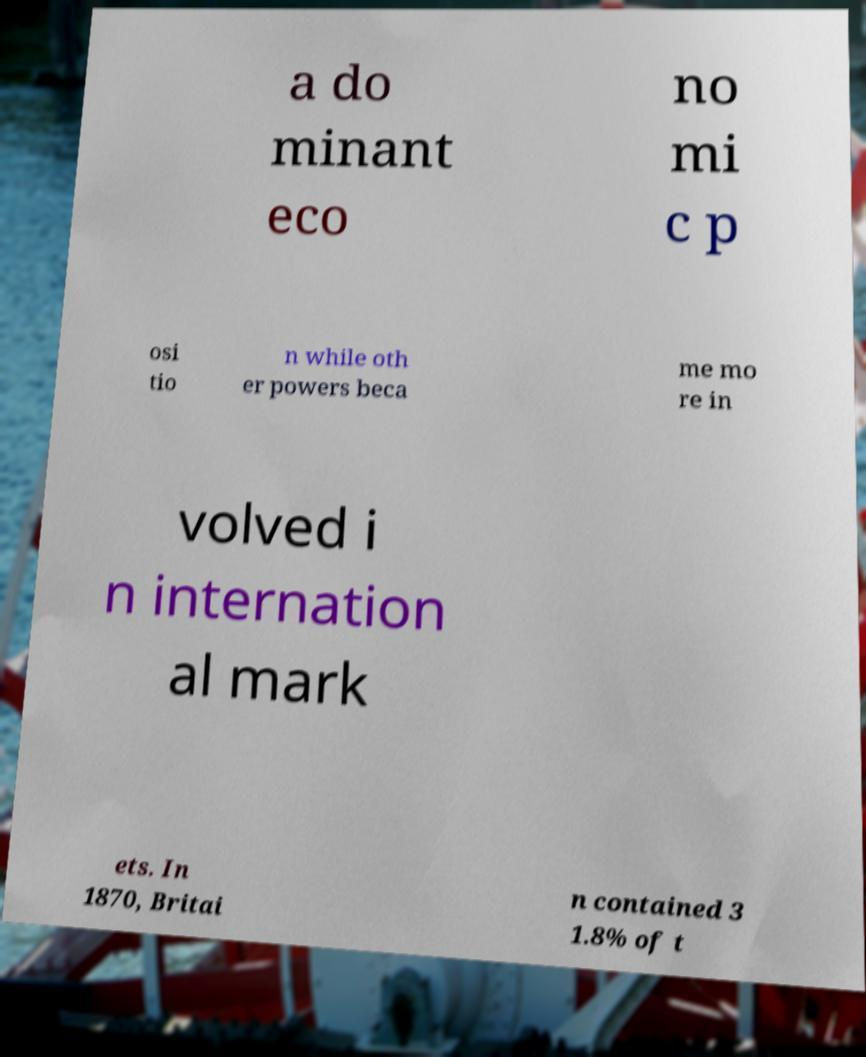Can you accurately transcribe the text from the provided image for me? a do minant eco no mi c p osi tio n while oth er powers beca me mo re in volved i n internation al mark ets. In 1870, Britai n contained 3 1.8% of t 